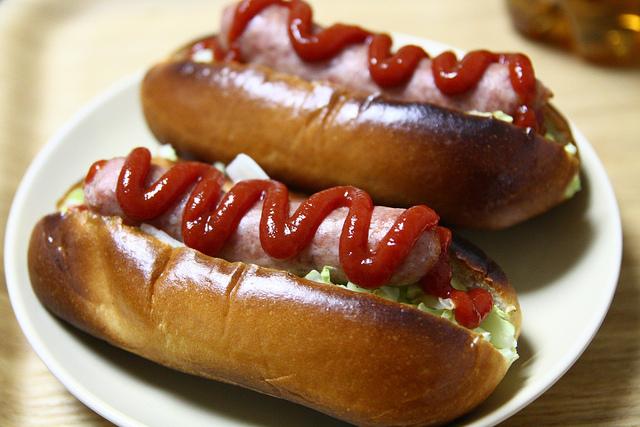Is the hotdog overcooked?
Short answer required. No. What sort of food is this?
Write a very short answer. Hot dog. What condiment do you see?
Answer briefly. Ketchup. 